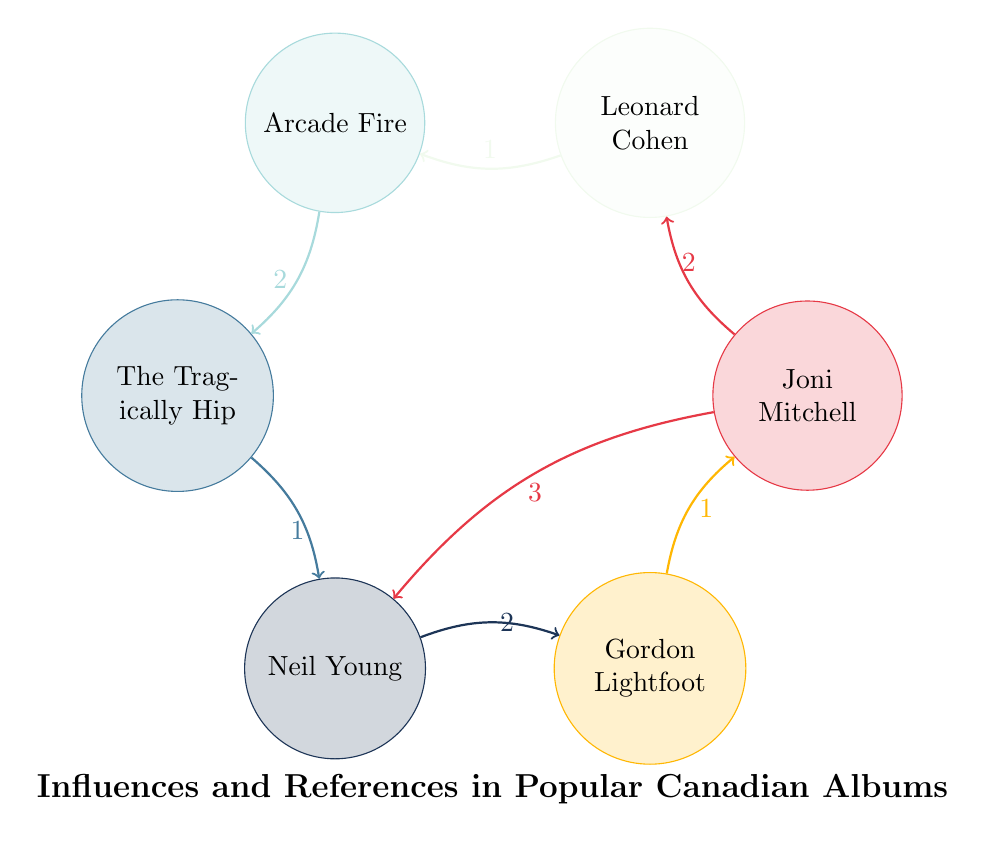What is the value of the connection between Joni Mitchell and Neil Young? The diagram shows an arrow connecting Joni Mitchell (JM) to Neil Young (NY) with the value labeled as 3. Therefore, the connection's value indicates how many times their influence is represented in the data.
Answer: 3 Which Canadian artist is referenced the most in the diagram? To determine this, we need to look for the node with the highest total values from outgoing links. Counting the values: Joni Mitchell (5), Leonard Cohen (1), Arcade Fire (2), The Tragically Hip (1), Neil Young (3), and Gordon Lightfoot (1), Joni Mitchell has the highest total with 5.
Answer: Joni Mitchell How many artists have a direct reference to Leonard Cohen? Looking closely at the diagram, the only arrow pointing away from Leonard Cohen leads to Arcade Fire with a value of 1. Thus, there is only one direct reference.
Answer: 1 What is the total number of nodes in the diagram? The nodes are Joni Mitchell, Leonard Cohen, Arcade Fire, The Tragically Hip, Neil Young, and Gordon Lightfoot. Counting these, we find there are a total of six nodes in the diagram.
Answer: 6 Which artist has a direct influence on Gordon Lightfoot? Checking the diagram, the only arrow pointing to Gordon Lightfoot is from Neil Young, indicating a direct influence between them.
Answer: Neil Young How many connections does Arcade Fire have in total? Looking at the diagram, Arcade Fire has two outgoing links: one to Leonard Cohen (1) and one to The Tragically Hip (2). Adding these values gives us a total of 3 connections.
Answer: 3 Which artist has an influence that directly connects to both Joni Mitchell and The Tragically Hip? Analyzing the connections, Neil Young influences Joni Mitchell (3) and has a connection to The Tragically Hip (1). Therefore, Neil Young connects both of these artists directly.
Answer: Neil Young What is the value of the relationship between The Tragically Hip and Neil Young? From the diagram, the value of the relationship represented by the arrow between The Tragically Hip and Neil Young is shown as 1.
Answer: 1 